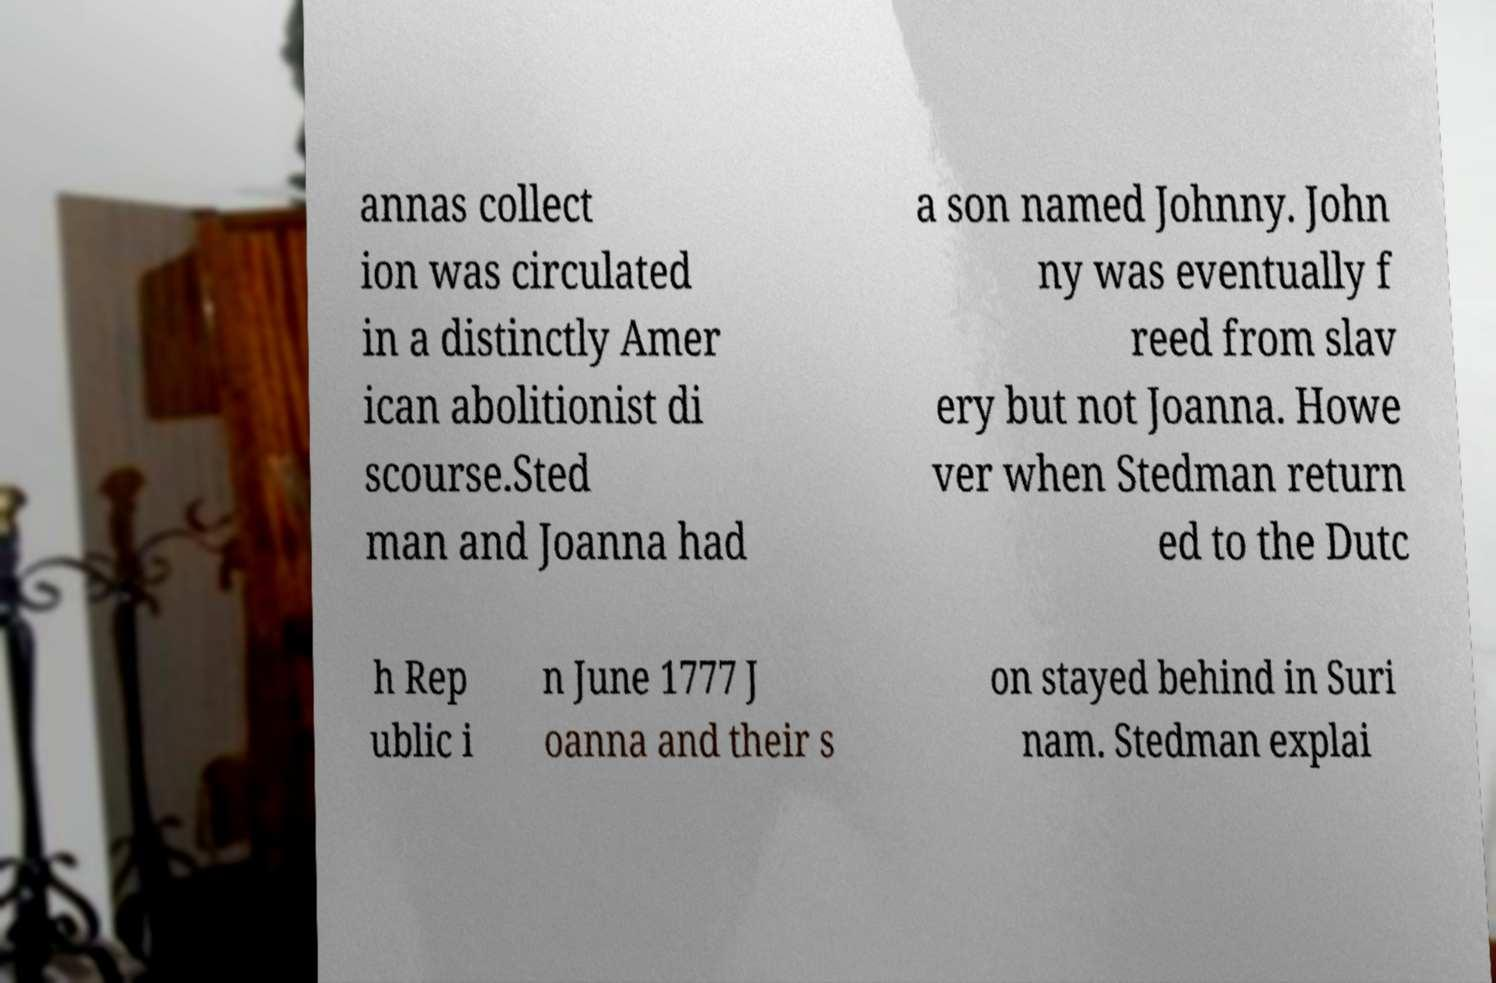What messages or text are displayed in this image? I need them in a readable, typed format. annas collect ion was circulated in a distinctly Amer ican abolitionist di scourse.Sted man and Joanna had a son named Johnny. John ny was eventually f reed from slav ery but not Joanna. Howe ver when Stedman return ed to the Dutc h Rep ublic i n June 1777 J oanna and their s on stayed behind in Suri nam. Stedman explai 